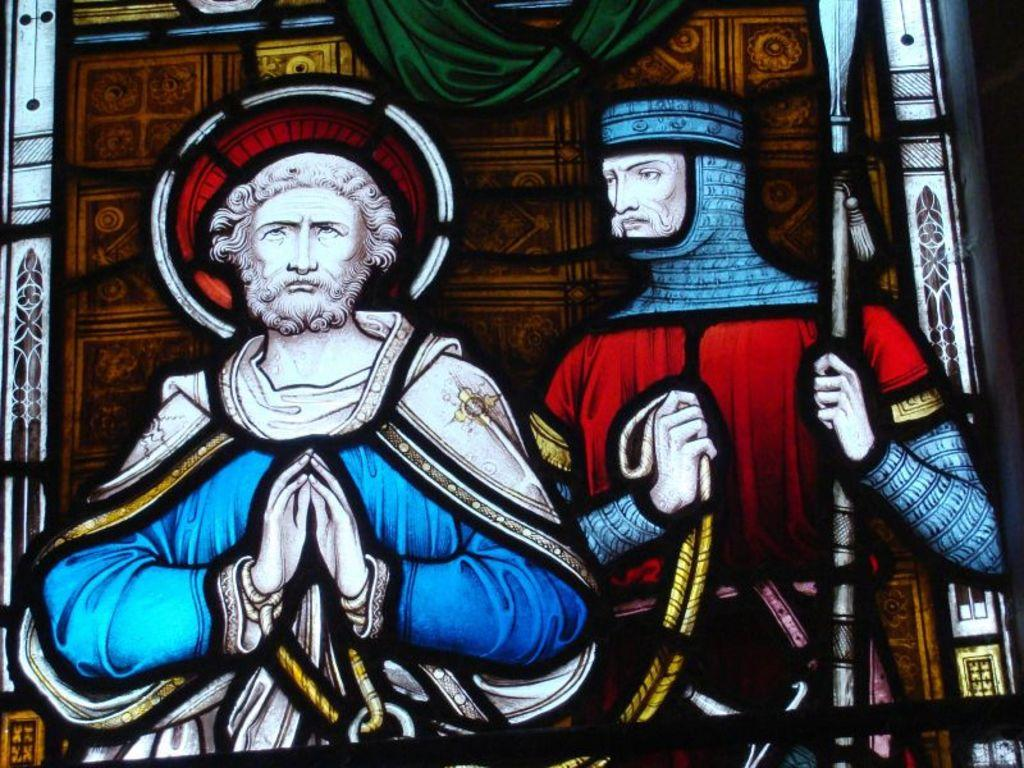What is depicted in the images in the picture? There are pictures of men in the image. What is the surface on which the pictures are displayed? The pictures are on a glass surface. What type of tax is being discussed in the image? There is no discussion of tax in the image; it features pictures of men on a glass surface. What is the source of fear in the image? There is no fear or any indication of fear in the image; it only contains pictures of men on a glass surface. 